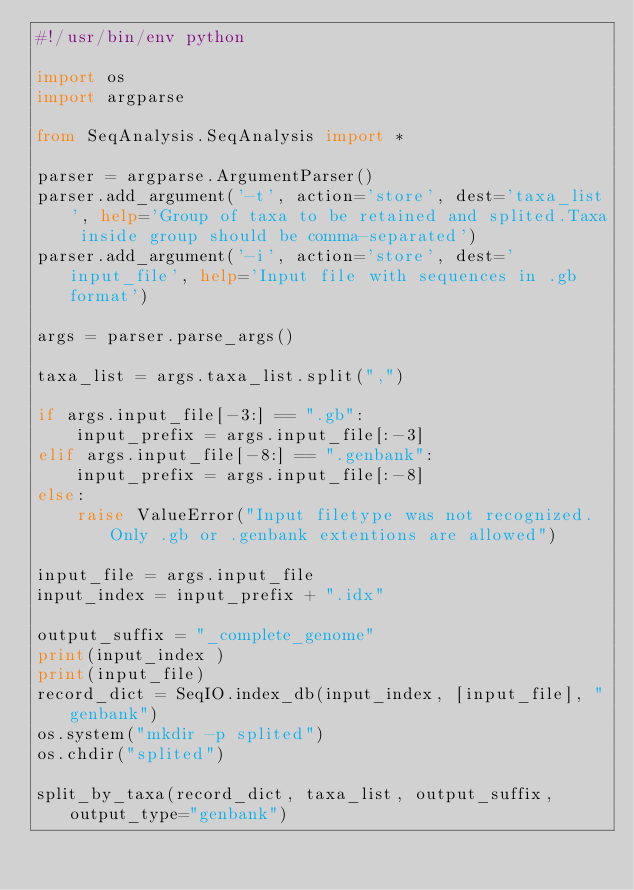Convert code to text. <code><loc_0><loc_0><loc_500><loc_500><_Python_>#!/usr/bin/env python

import os
import argparse

from SeqAnalysis.SeqAnalysis import *

parser = argparse.ArgumentParser()
parser.add_argument('-t', action='store', dest='taxa_list', help='Group of taxa to be retained and splited.Taxa inside group should be comma-separated')
parser.add_argument('-i', action='store', dest='input_file', help='Input file with sequences in .gb format')

args = parser.parse_args()

taxa_list = args.taxa_list.split(",")

if args.input_file[-3:] == ".gb":
	input_prefix = args.input_file[:-3]
elif args.input_file[-8:] == ".genbank":
	input_prefix = args.input_file[:-8]
else:
	raise ValueError("Input filetype was not recognized. Only .gb or .genbank extentions are allowed")

input_file = args.input_file
input_index = input_prefix + ".idx"

output_suffix = "_complete_genome"
print(input_index )
print(input_file)
record_dict = SeqIO.index_db(input_index, [input_file], "genbank")
os.system("mkdir -p splited")
os.chdir("splited")

split_by_taxa(record_dict, taxa_list, output_suffix, output_type="genbank")
	
</code> 